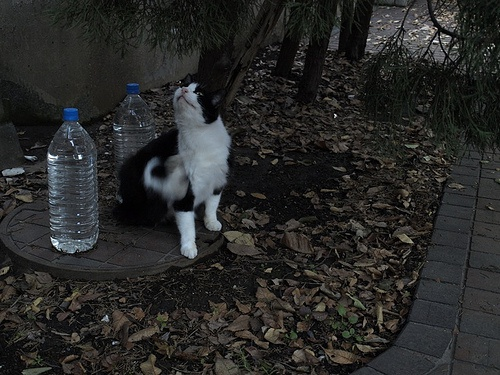Describe the objects in this image and their specific colors. I can see cat in black, darkgray, and gray tones, bottle in black, gray, and darkblue tones, and bottle in black and gray tones in this image. 